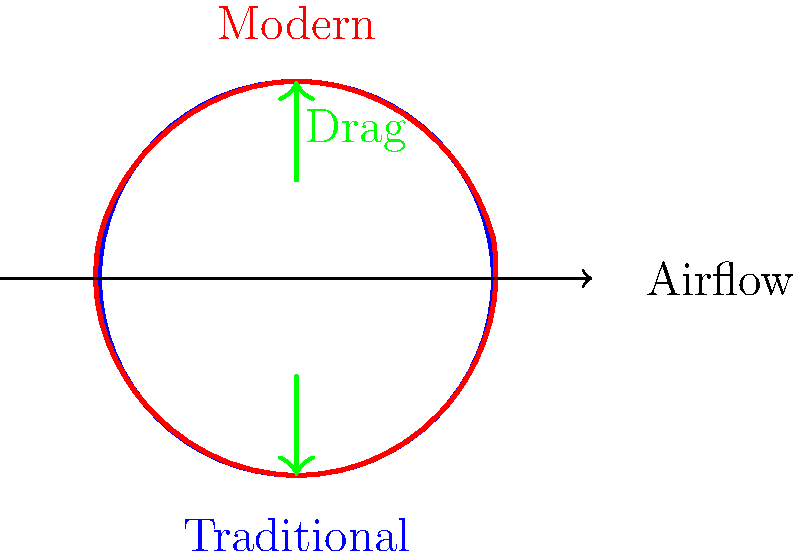Como a forma da bola de futebol moderna afeta sua aerodinâmica em comparação com a bola tradicional? Considere o coeficiente de arrasto ($C_d$) para sua resposta. Para entender como a forma da bola afeta sua aerodinâmica, vamos analisar passo a passo:

1. Forma da bola:
   - Bola tradicional: superfície lisa com costuras proeminentes
   - Bola moderna: superfície texturizada com painéis aerodinâmicos

2. Coeficiente de arrasto ($C_d$):
   - Mede a resistência do ar ao movimento da bola
   - Menor $C_d$ significa menor resistência ao ar

3. Efeito da superfície:
   - Superfície lisa (bola tradicional): camada limite se separa mais cedo, criando uma esteira turbulenta maior
   - Superfície texturizada (bola moderna): atrasa a separação da camada limite, reduzindo a esteira turbulenta

4. Resultado:
   - Bola tradicional: $C_d$ mais alto, em torno de 0.5
   - Bola moderna: $C_d$ mais baixo, em torno de 0.2

5. Impacto no jogo:
   - Bola moderna viaja mais longe com a mesma força aplicada
   - Trajetória mais estável e previsível
   - Possibilita chutes com efeitos mais pronunciados (curvas, knuckleballs)

Portanto, a forma moderna da bola de futebol reduz significativamente o coeficiente de arrasto, melhorando sua performance aerodinâmica em comparação com a bola tradicional.
Answer: A bola moderna tem menor coeficiente de arrasto ($C_d$), melhorando sua aerodinâmica. 